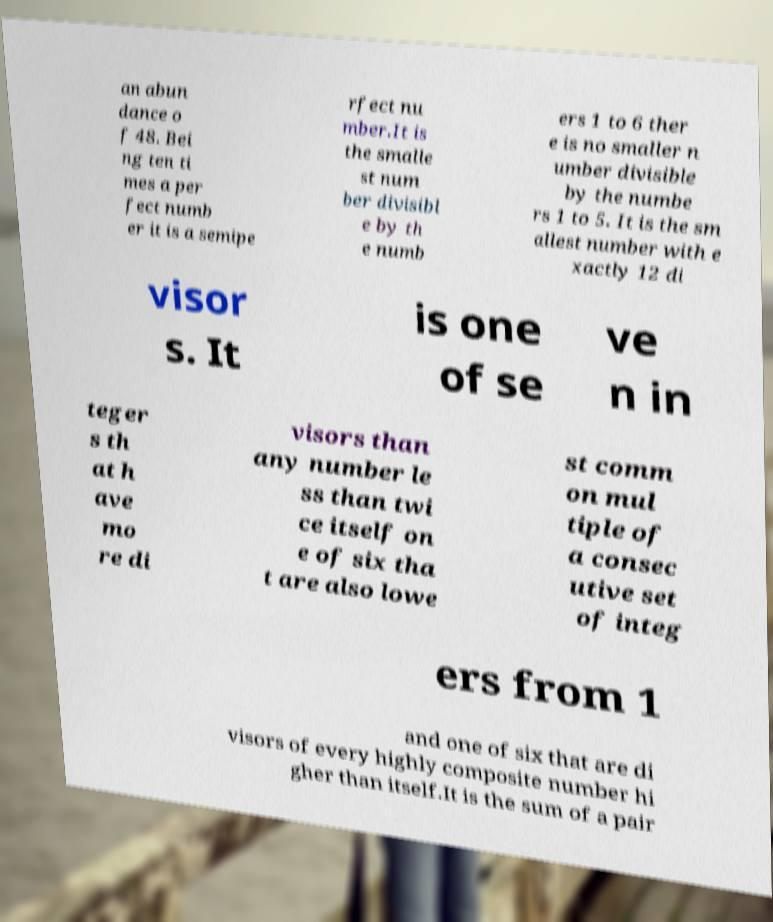Can you read and provide the text displayed in the image?This photo seems to have some interesting text. Can you extract and type it out for me? an abun dance o f 48. Bei ng ten ti mes a per fect numb er it is a semipe rfect nu mber.It is the smalle st num ber divisibl e by th e numb ers 1 to 6 ther e is no smaller n umber divisible by the numbe rs 1 to 5. It is the sm allest number with e xactly 12 di visor s. It is one of se ve n in teger s th at h ave mo re di visors than any number le ss than twi ce itself on e of six tha t are also lowe st comm on mul tiple of a consec utive set of integ ers from 1 and one of six that are di visors of every highly composite number hi gher than itself.It is the sum of a pair 